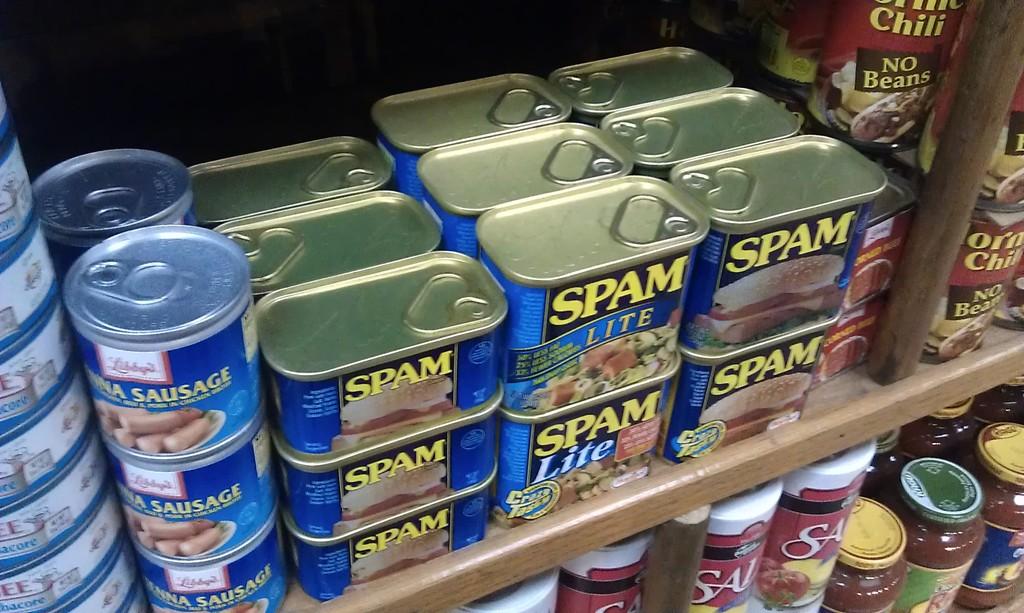What kind of lunch meat is this?
Keep it short and to the point. Spam. 